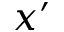<formula> <loc_0><loc_0><loc_500><loc_500>x ^ { \prime }</formula> 